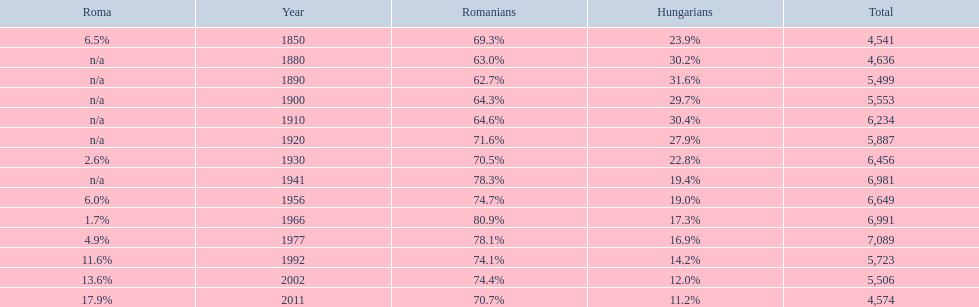What were the total number of times the romanians had a population percentage above 70%? 9. 